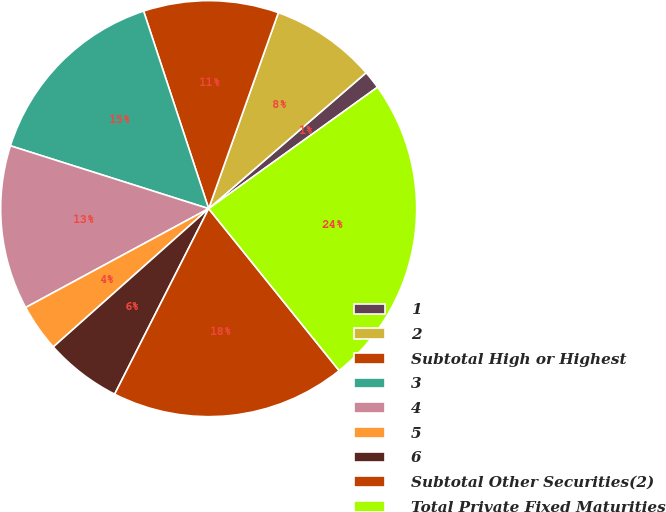Convert chart. <chart><loc_0><loc_0><loc_500><loc_500><pie_chart><fcel>1<fcel>2<fcel>Subtotal High or Highest<fcel>3<fcel>4<fcel>5<fcel>6<fcel>Subtotal Other Securities(2)<fcel>Total Private Fixed Maturities<nl><fcel>1.41%<fcel>8.23%<fcel>10.5%<fcel>15.05%<fcel>12.77%<fcel>3.69%<fcel>5.96%<fcel>18.26%<fcel>24.13%<nl></chart> 